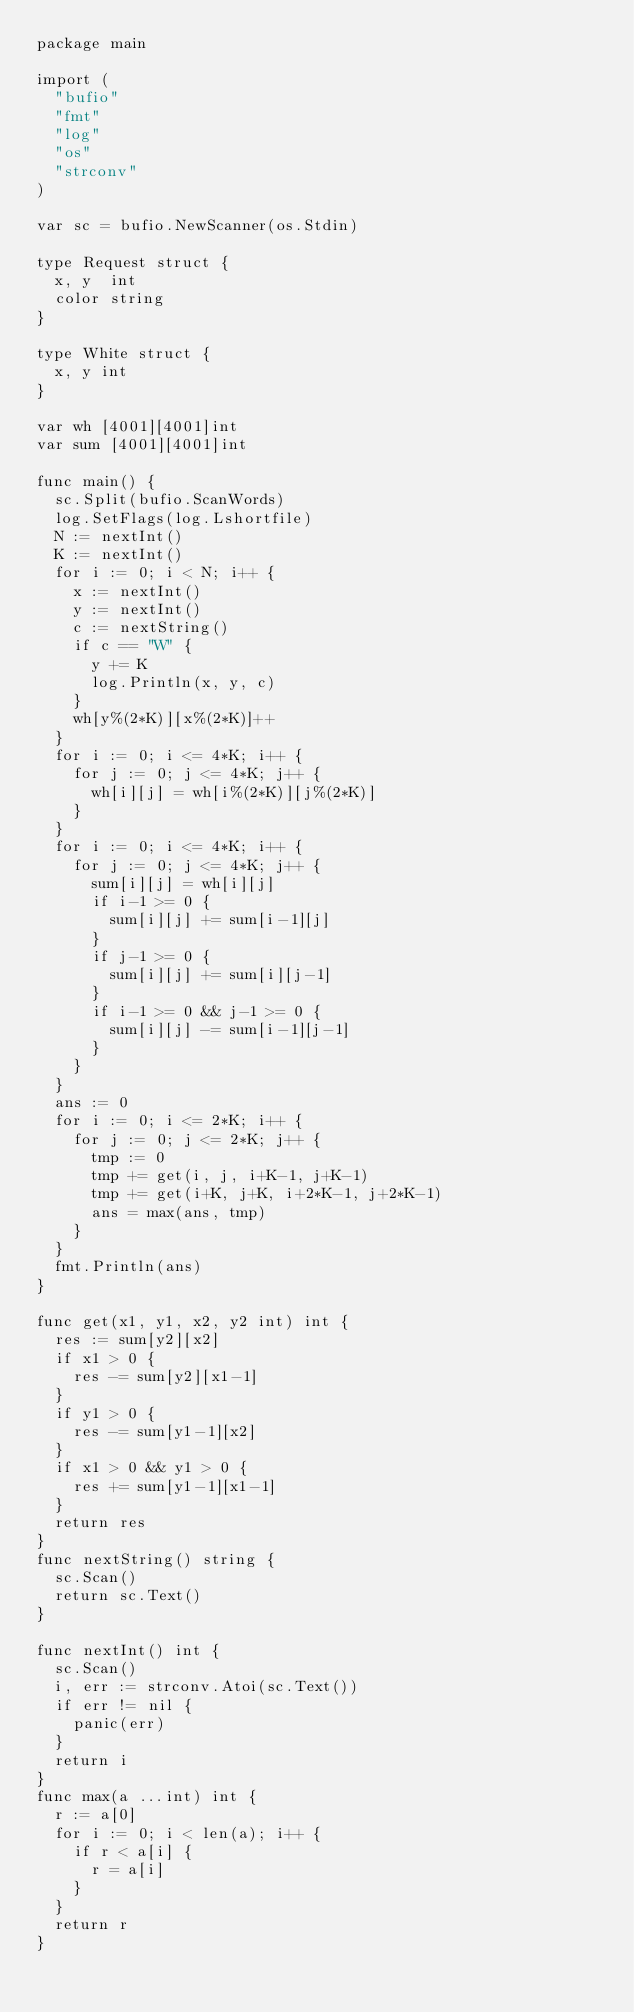Convert code to text. <code><loc_0><loc_0><loc_500><loc_500><_Go_>package main

import (
	"bufio"
	"fmt"
	"log"
	"os"
	"strconv"
)

var sc = bufio.NewScanner(os.Stdin)

type Request struct {
	x, y  int
	color string
}

type White struct {
	x, y int
}

var wh [4001][4001]int
var sum [4001][4001]int

func main() {
	sc.Split(bufio.ScanWords)
	log.SetFlags(log.Lshortfile)
	N := nextInt()
	K := nextInt()
	for i := 0; i < N; i++ {
		x := nextInt()
		y := nextInt()
		c := nextString()
		if c == "W" {
			y += K
			log.Println(x, y, c)
		}
		wh[y%(2*K)][x%(2*K)]++
	}
	for i := 0; i <= 4*K; i++ {
		for j := 0; j <= 4*K; j++ {
			wh[i][j] = wh[i%(2*K)][j%(2*K)]
		}
	}
	for i := 0; i <= 4*K; i++ {
		for j := 0; j <= 4*K; j++ {
			sum[i][j] = wh[i][j]
			if i-1 >= 0 {
				sum[i][j] += sum[i-1][j]
			}
			if j-1 >= 0 {
				sum[i][j] += sum[i][j-1]
			}
			if i-1 >= 0 && j-1 >= 0 {
				sum[i][j] -= sum[i-1][j-1]
			}
		}
	}
	ans := 0
	for i := 0; i <= 2*K; i++ {
		for j := 0; j <= 2*K; j++ {
			tmp := 0
			tmp += get(i, j, i+K-1, j+K-1)
			tmp += get(i+K, j+K, i+2*K-1, j+2*K-1)
			ans = max(ans, tmp)
		}
	}
	fmt.Println(ans)
}

func get(x1, y1, x2, y2 int) int {
	res := sum[y2][x2]
	if x1 > 0 {
		res -= sum[y2][x1-1]
	}
	if y1 > 0 {
		res -= sum[y1-1][x2]
	}
	if x1 > 0 && y1 > 0 {
		res += sum[y1-1][x1-1]
	}
	return res
}
func nextString() string {
	sc.Scan()
	return sc.Text()
}

func nextInt() int {
	sc.Scan()
	i, err := strconv.Atoi(sc.Text())
	if err != nil {
		panic(err)
	}
	return i
}
func max(a ...int) int {
	r := a[0]
	for i := 0; i < len(a); i++ {
		if r < a[i] {
			r = a[i]
		}
	}
	return r
}
</code> 